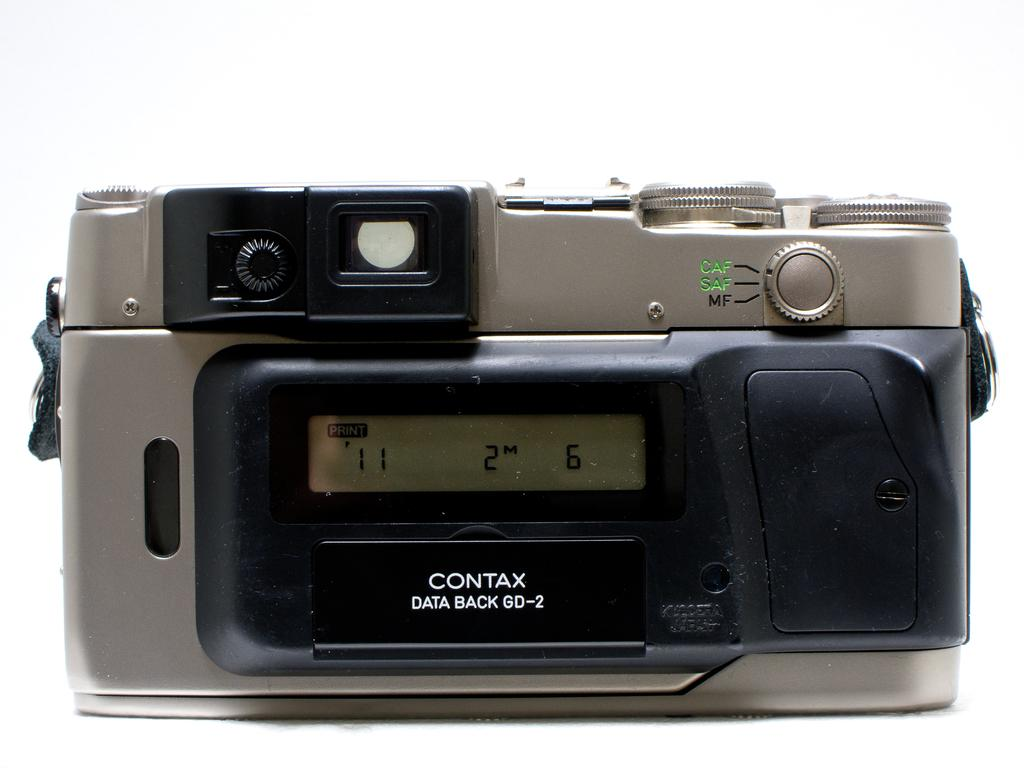What object is the main subject of the picture? The main subject of the picture is a camera. What features can be seen on the camera? The camera has buttons and a lens. What is the color of the surface the camera is placed on? The camera is placed on a white surface. Who won the competition between the camera and the mom in the image? There is no competition between the camera and a mom in the image, as the image only features a camera. What type of friction is present between the camera and the white surface? There is no information about friction between the camera and the white surface in the image, as the focus is on the camera's features and placement. 